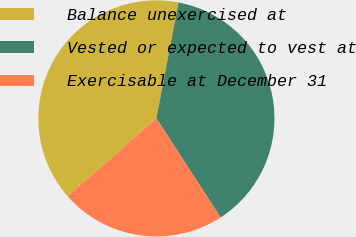Convert chart to OTSL. <chart><loc_0><loc_0><loc_500><loc_500><pie_chart><fcel>Balance unexercised at<fcel>Vested or expected to vest at<fcel>Exercisable at December 31<nl><fcel>39.46%<fcel>37.84%<fcel>22.7%<nl></chart> 